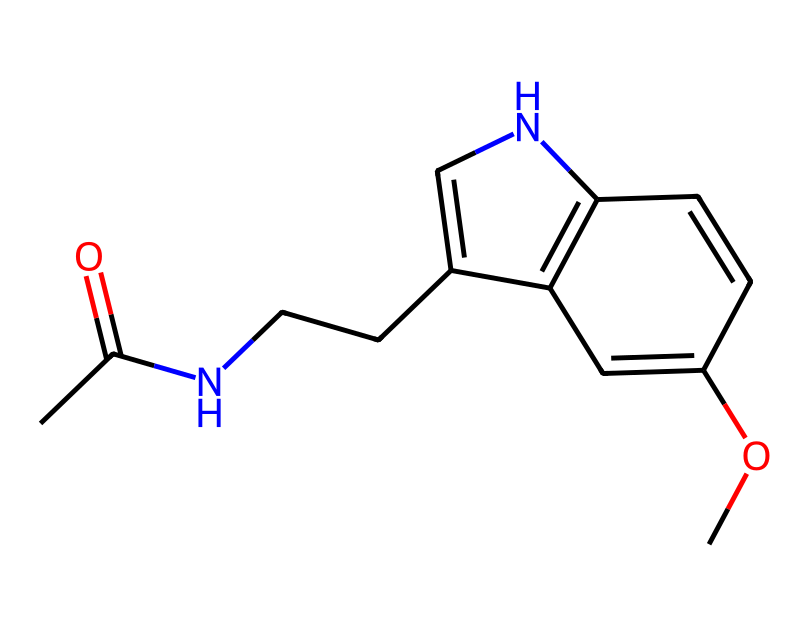What is the main functional group in melatonin? The molecular structure includes an acetyl group (–COCH3) and a nitrogen-containing heterocyclic ring. The carbonyl part of the acetyl group indicates the presence of ketone which is a functional group associated with many compounds, including melatonin.
Answer: acetyl group How many rings are present in the structure? Examining the structure closely, there are two fused rings formed by the carbon and nitrogen atoms arranged in a cyclic system, characteristic of many alkaloids.
Answer: two What is the total number of carbon atoms in the structure? Counting the carbon atoms in the structure as represented in the SMILES notation reveals there are 12 carbon atoms in total, considering the basic structure and functional groups.
Answer: twelve Does this chemical contain a heteroatom? Yes, the presence of nitrogen atoms suggests that the structure has heteroatoms, which are atoms in a ring that are not carbon.
Answer: yes What kind of biological activity is melatonin primarily known for? Melatonin is mainly known for its role as a sleep aid, helping to regulate sleep-wake cycles, especially useful during events like international fashion weeks that disrupt normal sleep patterns.
Answer: sleep aid Is this compound classified as a natural product or a synthetic compound? Melatonin is a natural product as it is produced in the body, although it can also be synthesized in laboratories for supplementation purposes.
Answer: natural product 